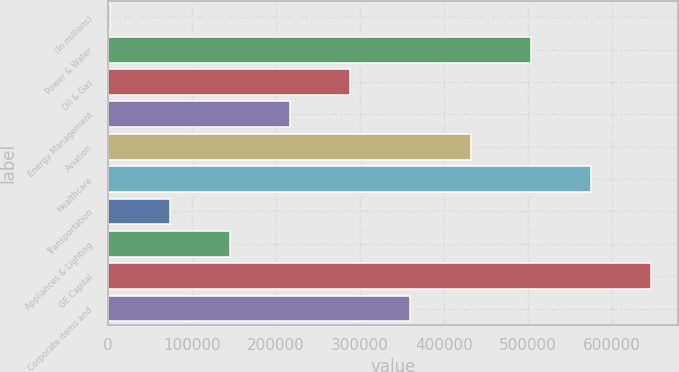Convert chart. <chart><loc_0><loc_0><loc_500><loc_500><bar_chart><fcel>(In millions)<fcel>Power & Water<fcel>Oil & Gas<fcel>Energy Management<fcel>Aviation<fcel>Healthcare<fcel>Transportation<fcel>Appliances & Lighting<fcel>GE Capital<fcel>Corporate items and<nl><fcel>2011<fcel>503205<fcel>288408<fcel>216809<fcel>431606<fcel>574805<fcel>73610.2<fcel>145209<fcel>646404<fcel>360007<nl></chart> 